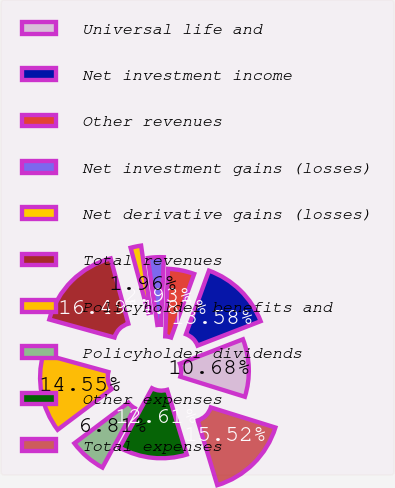Convert chart. <chart><loc_0><loc_0><loc_500><loc_500><pie_chart><fcel>Universal life and<fcel>Net investment income<fcel>Other revenues<fcel>Net investment gains (losses)<fcel>Net derivative gains (losses)<fcel>Total revenues<fcel>Policyholder benefits and<fcel>Policyholder dividends<fcel>Other expenses<fcel>Total expenses<nl><fcel>10.68%<fcel>13.58%<fcel>4.87%<fcel>2.93%<fcel>1.96%<fcel>16.49%<fcel>14.55%<fcel>6.81%<fcel>12.61%<fcel>15.52%<nl></chart> 